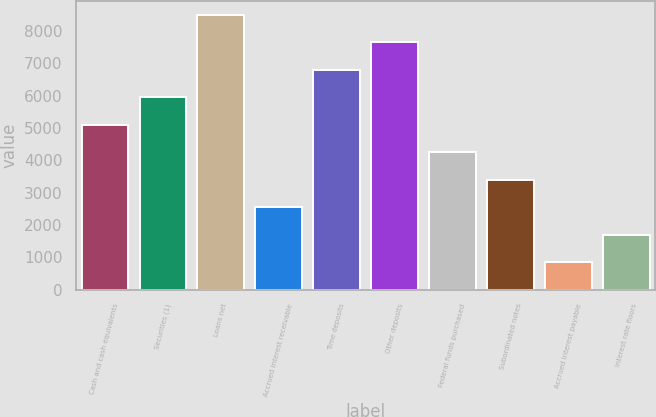Convert chart to OTSL. <chart><loc_0><loc_0><loc_500><loc_500><bar_chart><fcel>Cash and cash equivalents<fcel>Securities (1)<fcel>Loans net<fcel>Accrued interest receivable<fcel>Time deposits<fcel>Other deposits<fcel>Federal funds purchased<fcel>Subordinated notes<fcel>Accrued interest payable<fcel>Interest rate floors<nl><fcel>5098.9<fcel>5948.65<fcel>8497.9<fcel>2549.65<fcel>6798.4<fcel>7648.15<fcel>4249.15<fcel>3399.4<fcel>850.15<fcel>1699.9<nl></chart> 